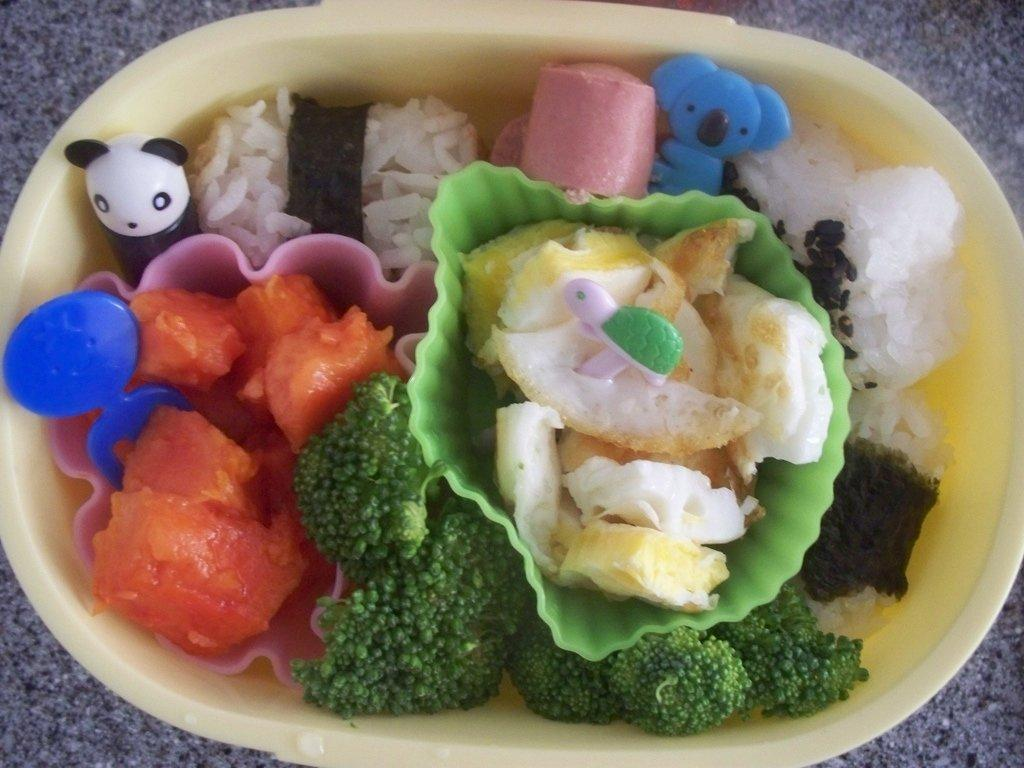What is the main object in the center of the image? There is a bowl in the center of the image. What is inside the bowl? The bowl contains food. Where is the bowl located? The bowl is present on the floor. What type of badge is visible on the food in the image? There is no badge present on the food in the image. 